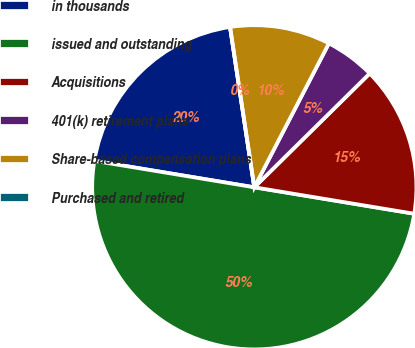Convert chart to OTSL. <chart><loc_0><loc_0><loc_500><loc_500><pie_chart><fcel>in thousands<fcel>issued and outstanding<fcel>Acquisitions<fcel>401(k) retirement plans<fcel>Share-based compensation plans<fcel>Purchased and retired<nl><fcel>20.0%<fcel>50.0%<fcel>15.0%<fcel>5.0%<fcel>10.0%<fcel>0.0%<nl></chart> 